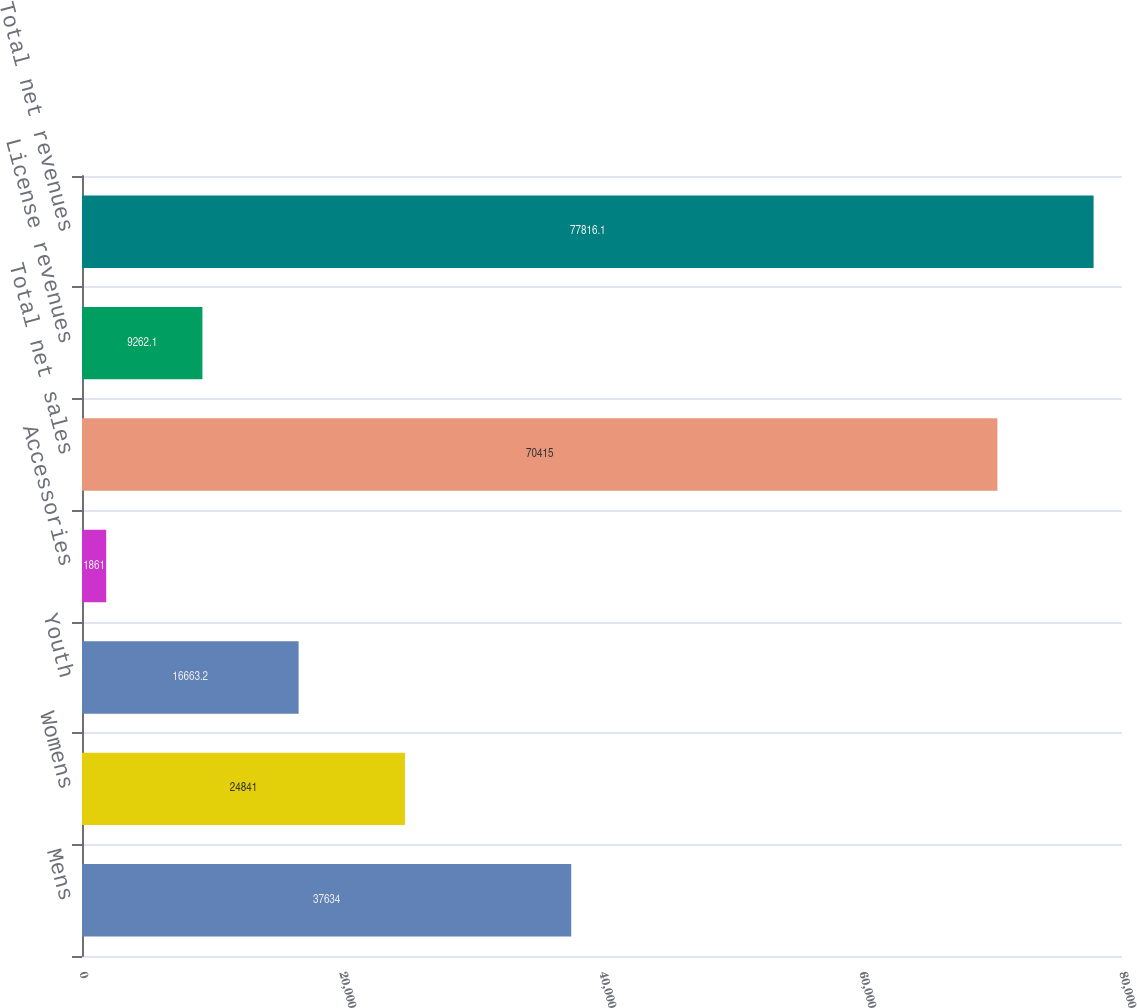Convert chart. <chart><loc_0><loc_0><loc_500><loc_500><bar_chart><fcel>Mens<fcel>Womens<fcel>Youth<fcel>Accessories<fcel>Total net sales<fcel>License revenues<fcel>Total net revenues<nl><fcel>37634<fcel>24841<fcel>16663.2<fcel>1861<fcel>70415<fcel>9262.1<fcel>77816.1<nl></chart> 